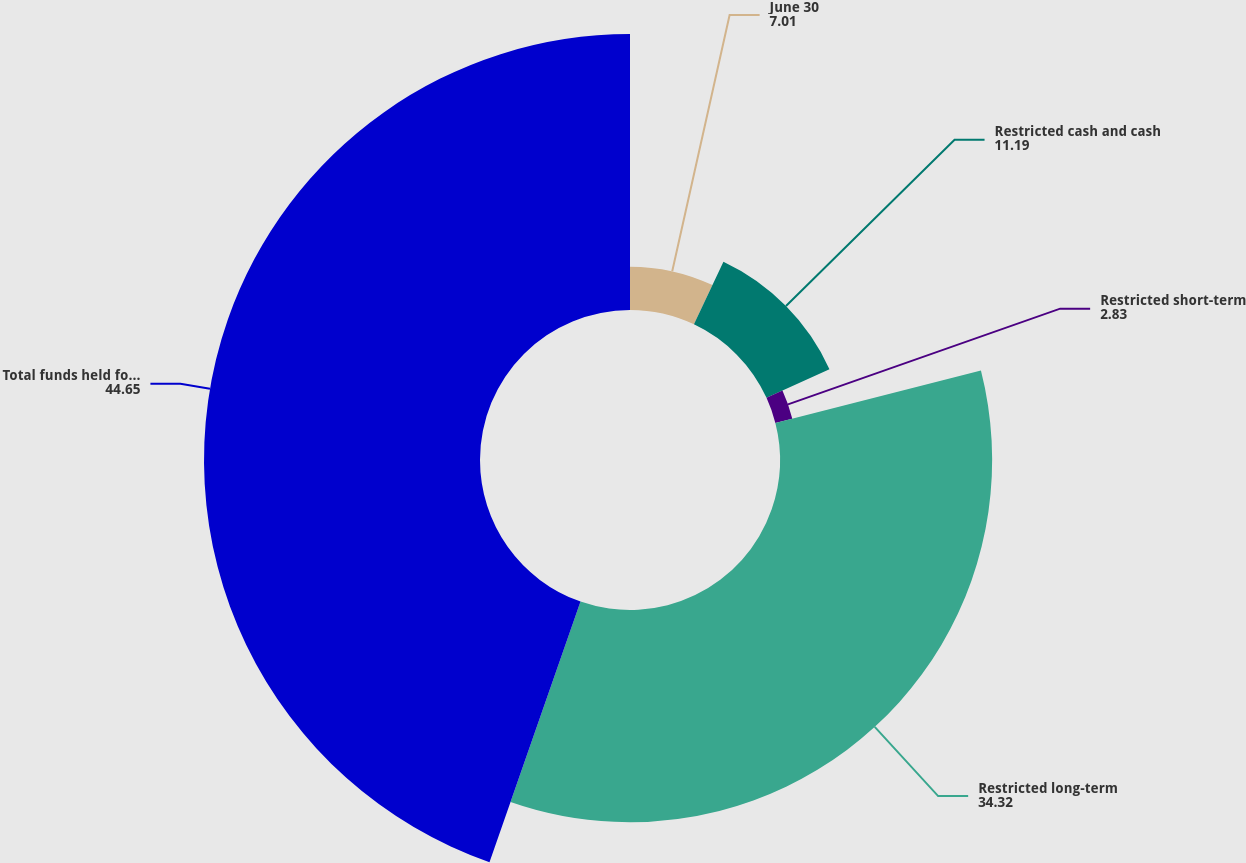<chart> <loc_0><loc_0><loc_500><loc_500><pie_chart><fcel>June 30<fcel>Restricted cash and cash<fcel>Restricted short-term<fcel>Restricted long-term<fcel>Total funds held for clients<nl><fcel>7.01%<fcel>11.19%<fcel>2.83%<fcel>34.32%<fcel>44.65%<nl></chart> 